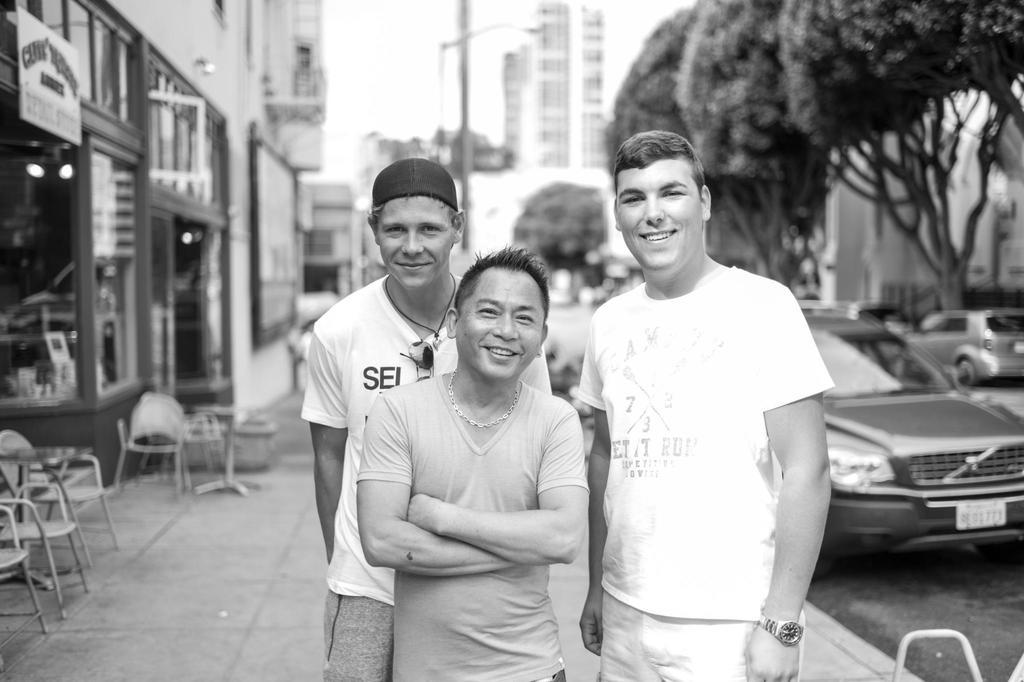What is the color scheme of the image? The image is black and white. How many people are in the image? There are three people standing in the image. What is the facial expression of the people in the image? The people are smiling. What can be seen in the background of the image? There are buildings, trees, vehicles, a pole, chairs, and the sky visible in the background of the image. What type of stone is being used to attack the buildings in the image? There is no stone or attack present in the image; it features three people smiling with various elements in the background. 